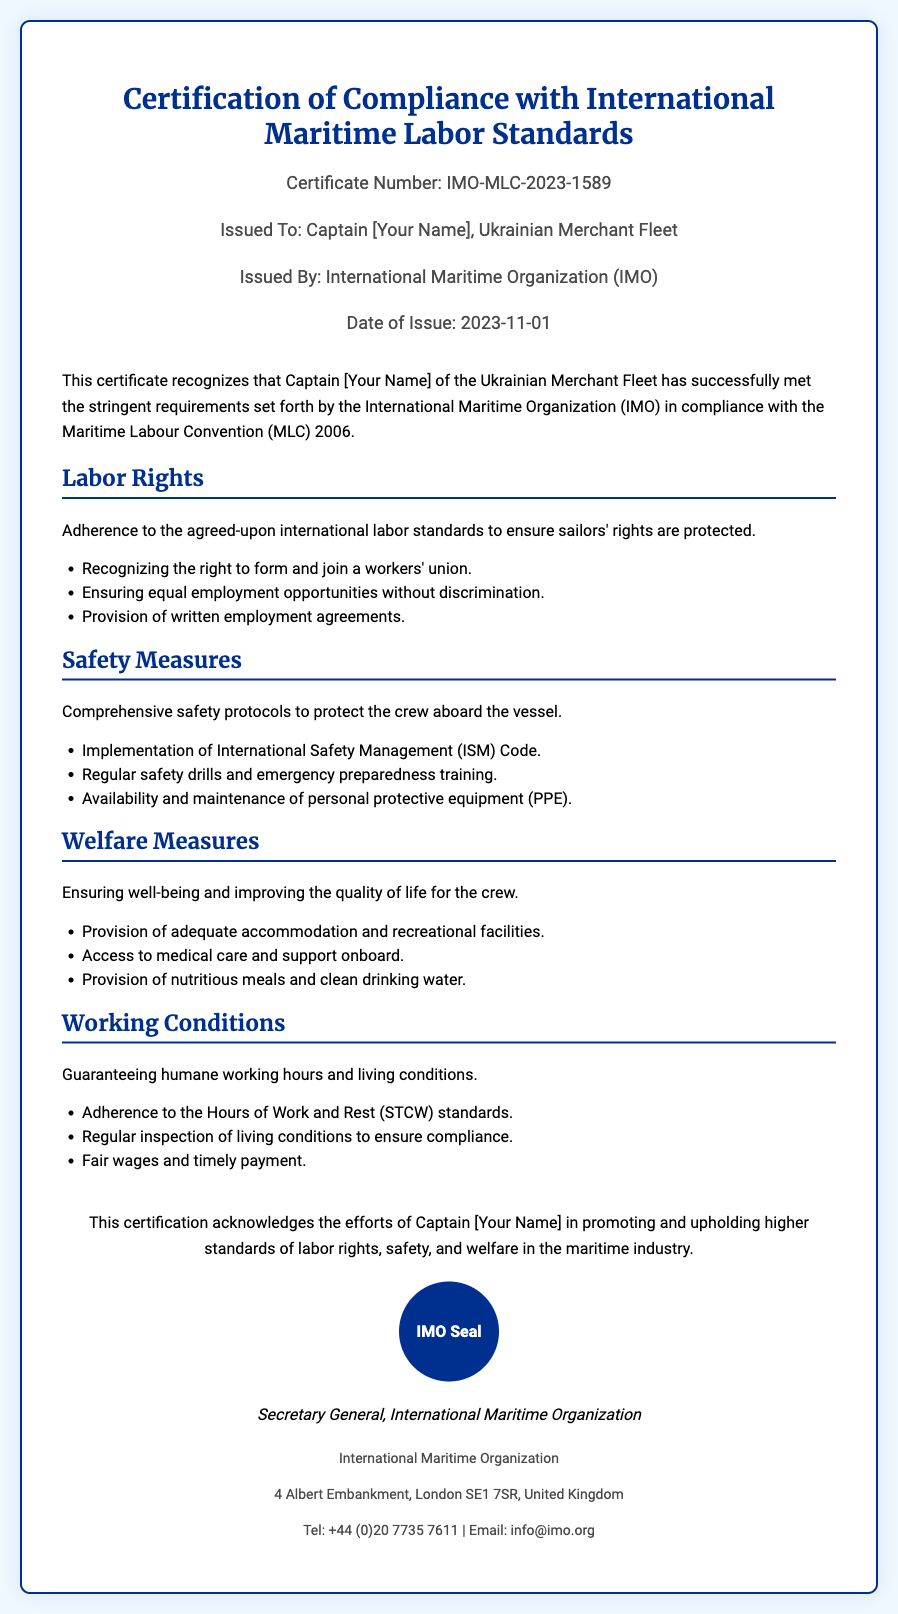What is the certificate number? The certificate number is listed prominently in the document, indicating the unique identifier for this certification.
Answer: IMO-MLC-2023-1589 Who issued the certificate? The issuer of the certificate is stated in the document, confirming the responsible organization for the certification.
Answer: International Maritime Organization (IMO) What date was the certificate issued? The date of issue is clearly specified in the document, marking the official recognition date.
Answer: 2023-11-01 What is the main purpose of this certificate? The purpose of the certificate is described in the introduction of the document, summarizing its significance.
Answer: Certification of Compliance with International Maritime Labor Standards Name one labor right listed in the document. The document outlines several labor rights, providing examples for better understanding.
Answer: Right to form and join a workers' union What safety protocol is implemented on the vessel? The document mentions specific safety protocols that are mandatory for maritime operations, highlighting the commitment to safety.
Answer: International Safety Management (ISM) Code What does the certificate recognize about Captain [Your Name]? The document emphasizes the acknowledgment of Captain [Your Name]'s contributions to maritime labor standards.
Answer: Promoting and upholding higher standards of labor rights, safety, and welfare What type of welfare measures are provided to the crew? Welfare measures are clearly outlined in the document, addressing the well-being of the crew.
Answer: Access to medical care and support onboard How are working conditions ensured according to the document? The document details specific standards and inspections to ensure humane working conditions on board.
Answer: Adherence to the Hours of Work and Rest (STCW) standards 